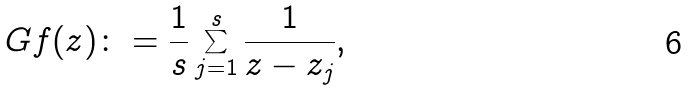Convert formula to latex. <formula><loc_0><loc_0><loc_500><loc_500>\ G f ( z ) \colon = \frac { 1 } { s } \sum _ { j = 1 } ^ { s } \frac { 1 } { z - z _ { j } } ,</formula> 